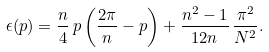Convert formula to latex. <formula><loc_0><loc_0><loc_500><loc_500>\epsilon ( p ) = \frac { n } { 4 } \, p \left ( \frac { 2 \pi } { n } - p \right ) + \frac { n ^ { 2 } - 1 } { 1 2 n } \, \frac { \pi ^ { 2 } } { N ^ { 2 } } .</formula> 